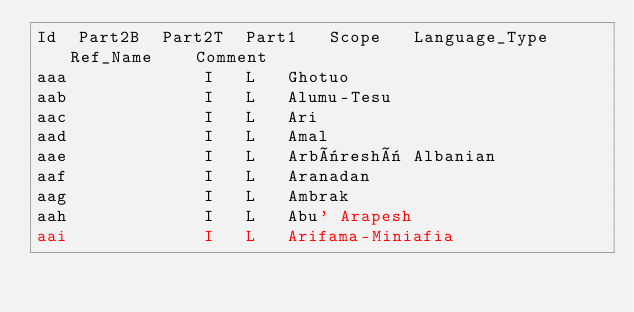<code> <loc_0><loc_0><loc_500><loc_500><_SQL_>Id	Part2B	Part2T	Part1	Scope	Language_Type	Ref_Name	Comment
aaa				I	L	Ghotuo	
aab				I	L	Alumu-Tesu	
aac				I	L	Ari	
aad				I	L	Amal	
aae				I	L	Arbëreshë Albanian	
aaf				I	L	Aranadan	
aag				I	L	Ambrak	
aah				I	L	Abu' Arapesh	
aai				I	L	Arifama-Miniafia	
</code> 